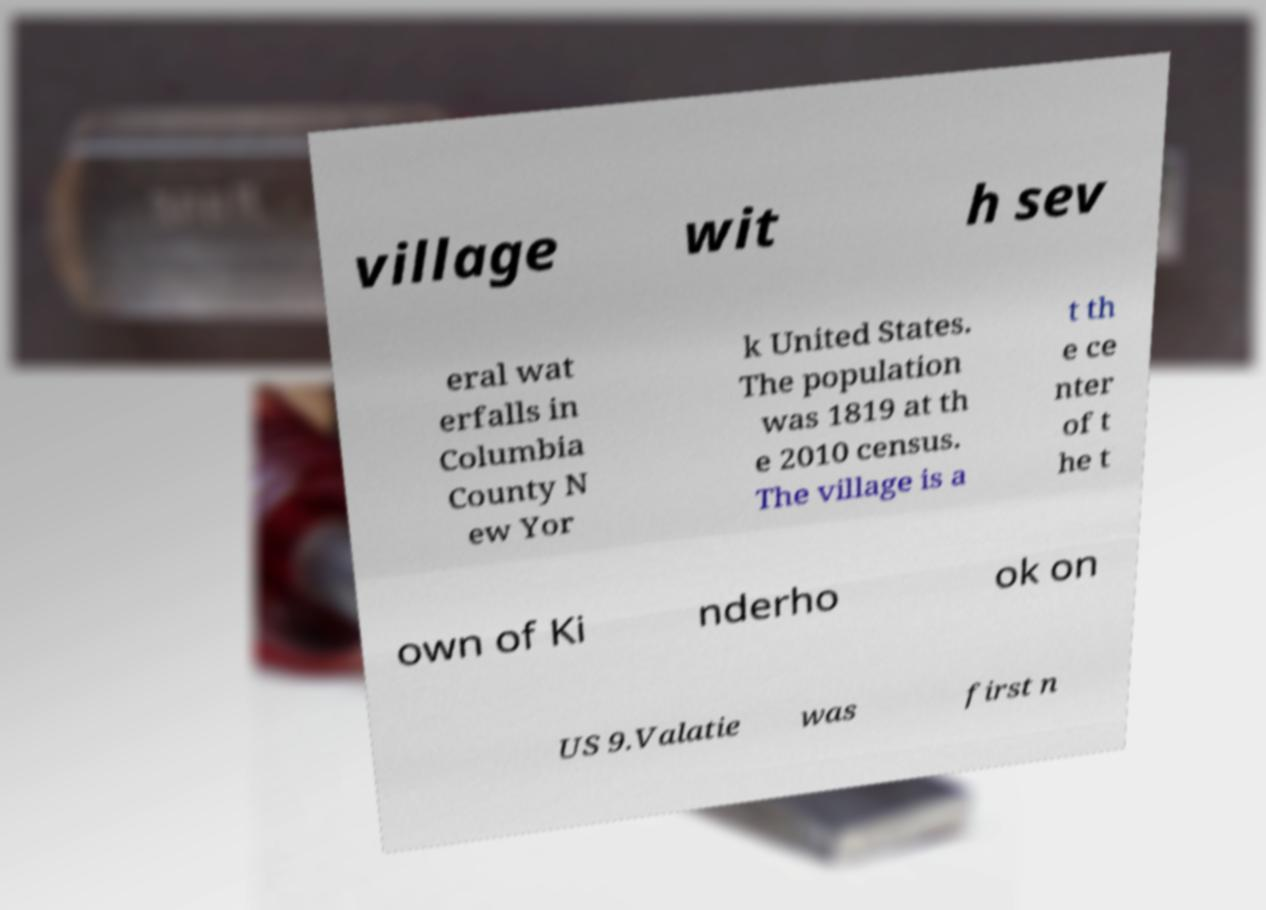Please identify and transcribe the text found in this image. village wit h sev eral wat erfalls in Columbia County N ew Yor k United States. The population was 1819 at th e 2010 census. The village is a t th e ce nter of t he t own of Ki nderho ok on US 9.Valatie was first n 